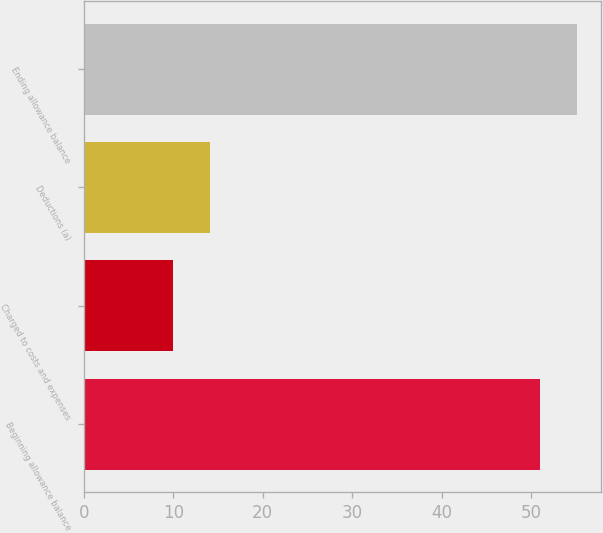Convert chart to OTSL. <chart><loc_0><loc_0><loc_500><loc_500><bar_chart><fcel>Beginning allowance balance<fcel>Charged to costs and expenses<fcel>Deductions (a)<fcel>Ending allowance balance<nl><fcel>51<fcel>10<fcel>14.1<fcel>55.1<nl></chart> 